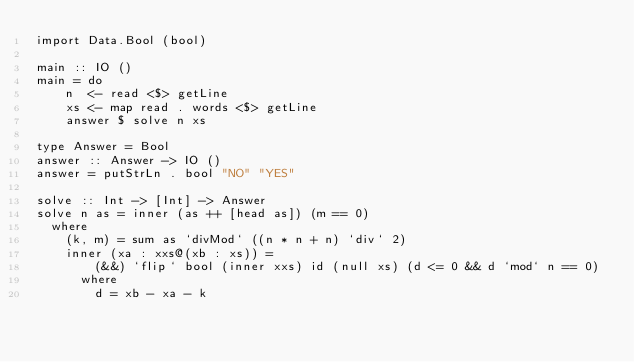Convert code to text. <code><loc_0><loc_0><loc_500><loc_500><_Haskell_>import Data.Bool (bool)

main :: IO ()
main = do
    n  <- read <$> getLine
    xs <- map read . words <$> getLine
    answer $ solve n xs

type Answer = Bool
answer :: Answer -> IO ()
answer = putStrLn . bool "NO" "YES"

solve :: Int -> [Int] -> Answer
solve n as = inner (as ++ [head as]) (m == 0)
  where
    (k, m) = sum as `divMod` ((n * n + n) `div` 2)
    inner (xa : xxs@(xb : xs)) =
        (&&) `flip` bool (inner xxs) id (null xs) (d <= 0 && d `mod` n == 0)
      where
        d = xb - xa - k
</code> 